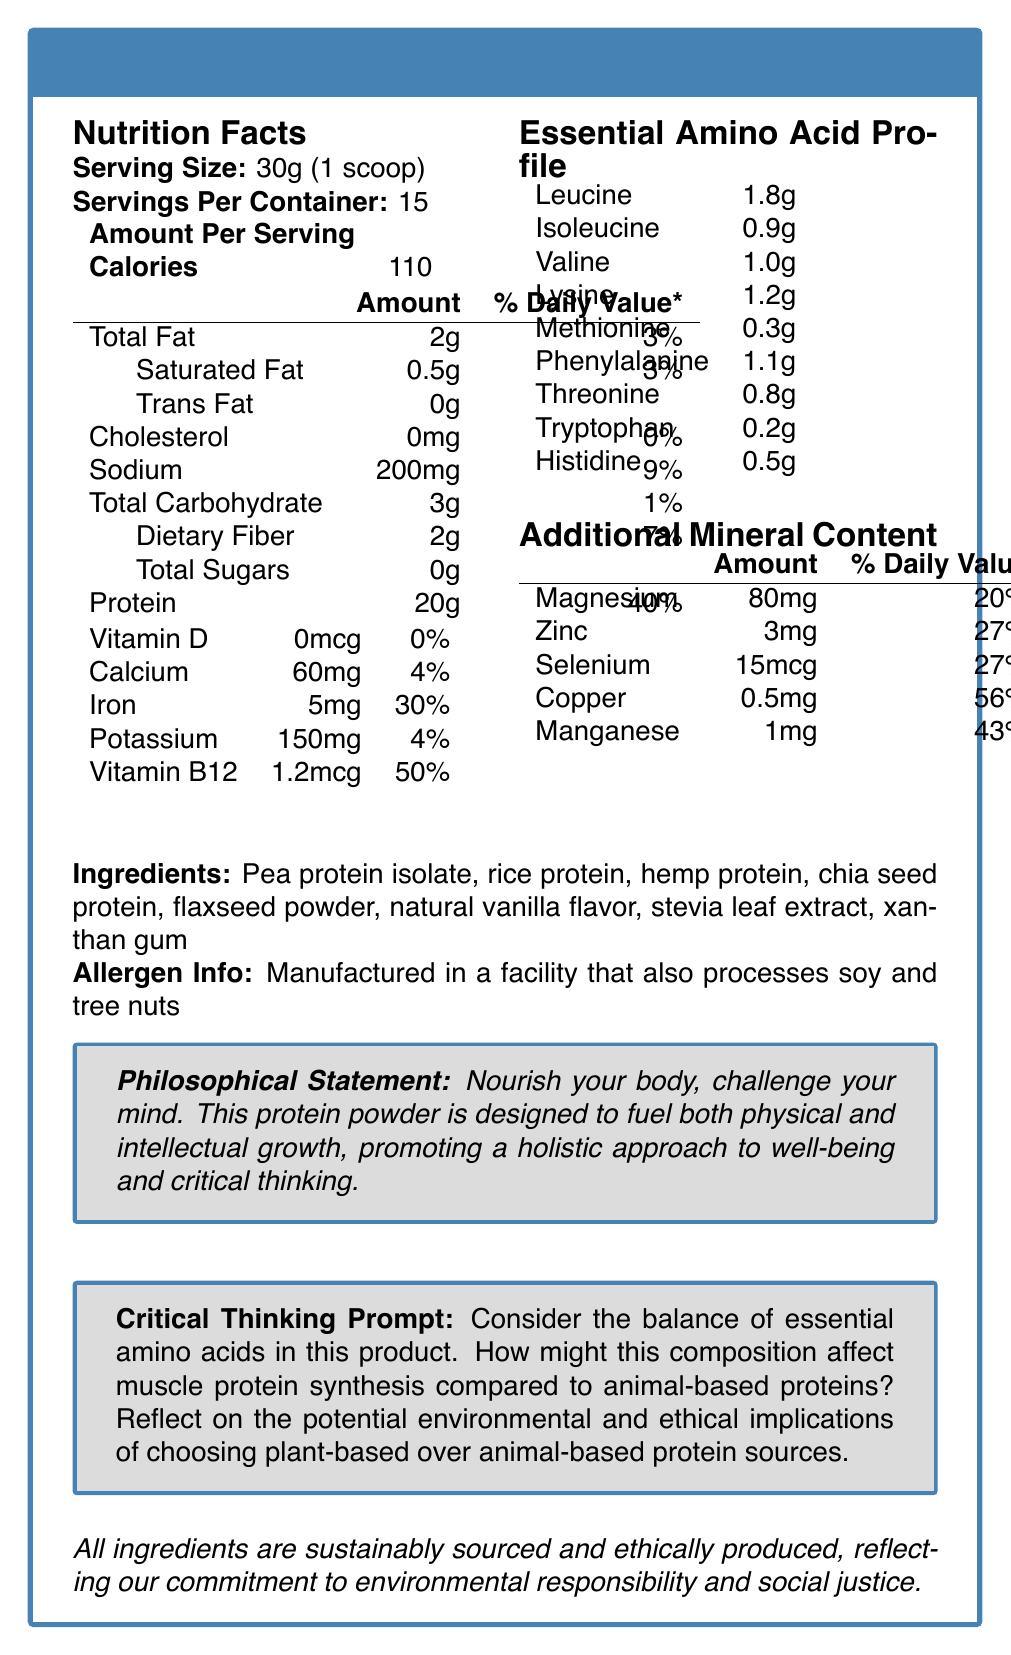What is the serving size of PhilosoPhuel Plant Protein? The serving size is clearly mentioned in the Nutrition Facts section as 30g (1 scoop).
Answer: 30g (1 scoop) How many servings are there per container? The document states there are 15 servings per container in the Nutrition Facts section.
Answer: 15 How much protein is in one serving of PhilosoPhuel Plant Protein? According to the Nutrition Facts section, one serving contains 20g of protein.
Answer: 20g Which essential amino acid has the highest amount per serving? The Essential Amino Acid Profile lists Leucine at 1.8g, which is the highest among the listed amino acids.
Answer: Leucine What percentage of the Daily Value for iron does one serving provide? The Nutrition Facts section states that one serving provides 30% of the Daily Value for iron.
Answer: 30% Which of the following minerals has the highest percentage of the Daily Value per serving? A. Calcium B. Zinc C. Copper D. Manganese The additional mineral content section shows that Copper has the highest percentage of Daily Value at 56%.
Answer: C. Copper How much dietary fiber does each serving contain? A. 7g B. 2g C. 1g D. 0g The Nutrition Facts section shows each serving contains 2g of dietary fiber.
Answer: B. 2g Is there any cholesterol in PhilosoPhuel Plant Protein? The Nutrition Facts section indicates that the product contains 0mg of cholesterol.
Answer: No Is PhilosoPhuel Plant Protein suitable for people with soy allergies? Although the product itself may not contain soy, the allergen info states it is manufactured in a facility that also processes soy.
Answer: No Summarize the main idea of the PhilosoPhuel Plant Protein document. The document details the nutritional content, ingredients, philosophical and ethical commitments of the product, and prompts consumers to engage in critical thinking regarding their protein choices.
Answer: PhilosoPhuel Plant Protein provides a comprehensive profile of essential nutrients, including a strong amino acid profile and various minerals, designed to nourish both the body and mind. It emphasizes sustainability, ethical sourcing, and the promotion of critical thinking. How might the amino acid composition affect muscle protein synthesis compared to animal-based proteins? The document prompts this question as a critical thinking exercise, but does not provide comparative data on muscle protein synthesis between plant-based and animal-based proteins.
Answer: Cannot be determined What is the percentage of the Daily Value for Vitamin B12 in one serving? The Nutrition Facts section specifies that one serving provides 50% of the Daily Value for Vitamin B12.
Answer: 50% Which ingredient is not part of PhilosoPhuel Plant Protein? A. Stevia leaf extract B. Xanthan gum C. Soy protein D. Hemp protein The ingredients list does not include soy protein, while the others are present.
Answer: C. Soy protein How much sodium is in one serving, and what is its Daily Value percentage? One serving contains 200mg of sodium, which is 9% of the Daily Value, as shown in the Nutrition Facts section.
Answer: 200mg; 9% Does PhilosoPhuel Plant Protein contain any sugars? According to the Nutrition Facts section, the product contains 0g of total sugars.
Answer: No 